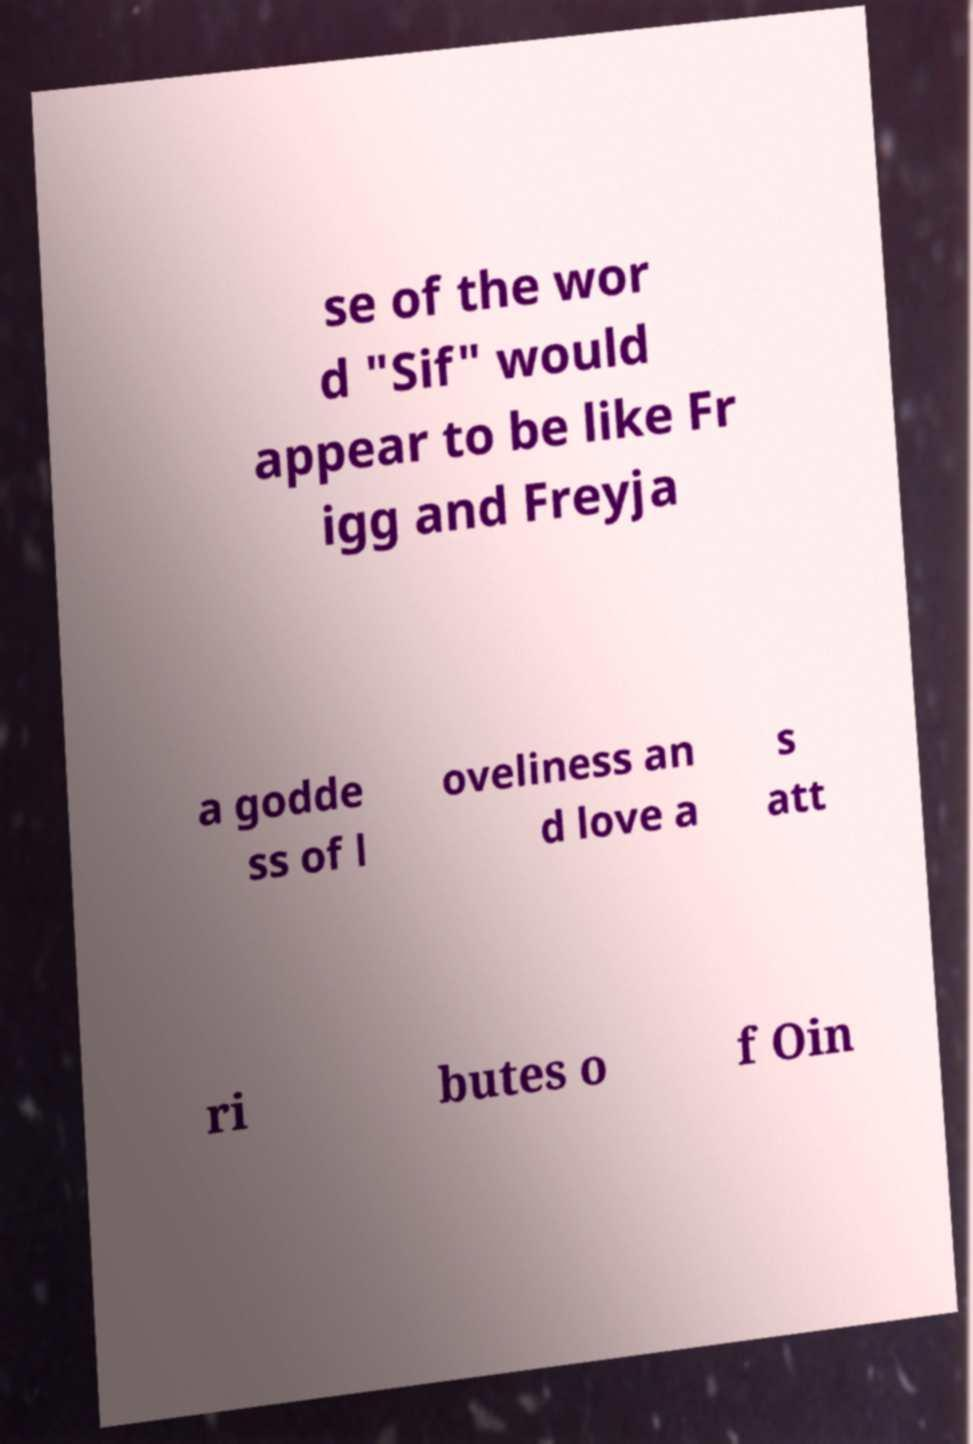I need the written content from this picture converted into text. Can you do that? se of the wor d "Sif" would appear to be like Fr igg and Freyja a godde ss of l oveliness an d love a s att ri butes o f Oin 